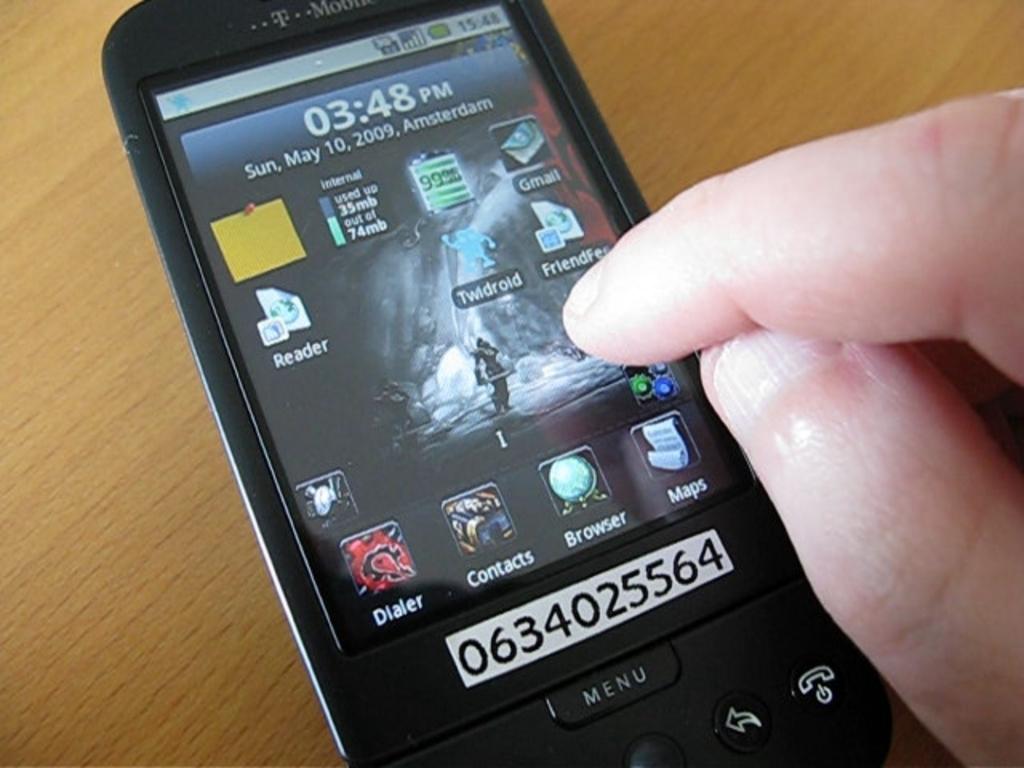What date is shown on the phone?
Your answer should be compact. May 10, 2009. What time is shown on the phone?
Keep it short and to the point. 3:48 pm. 